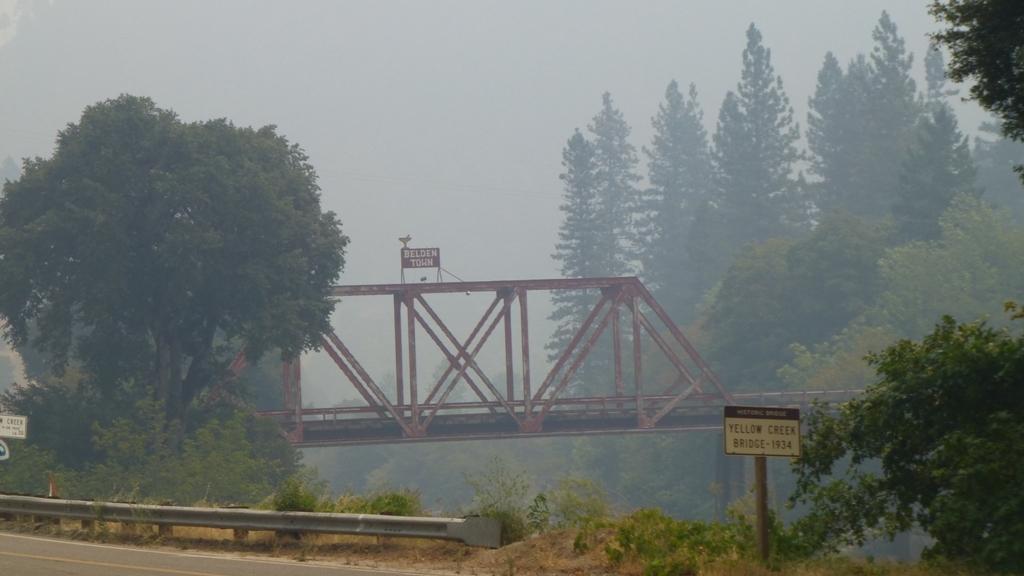How would you summarize this image in a sentence or two? In this image there is a metal bridge having a board attached to it. Left bottom there is a road. Beside there is a fence. Bottom of the image there are few plants on the land. Right bottom there is a pole having a board attached to it. Right side there are few trees. Top of the image there is sky. Background there are few trees. 